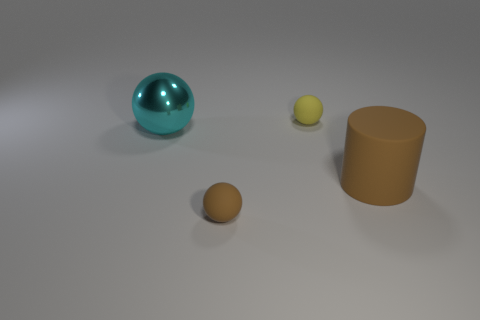There is a ball that is the same color as the matte cylinder; what is it made of?
Give a very brief answer. Rubber. Are the object that is behind the big metallic ball and the big cyan object made of the same material?
Give a very brief answer. No. Is there anything else that is made of the same material as the cyan sphere?
Provide a short and direct response. No. Are there any tiny objects of the same color as the large rubber thing?
Provide a short and direct response. Yes. Do the yellow thing and the metallic thing have the same shape?
Your answer should be very brief. Yes. There is a large cylinder that is made of the same material as the tiny yellow object; what is its color?
Your answer should be compact. Brown. How many things are either small rubber spheres that are in front of the big cyan sphere or cyan things?
Your response must be concise. 2. What is the size of the rubber thing that is behind the big brown object?
Give a very brief answer. Small. Does the metallic ball have the same size as the rubber object that is right of the tiny yellow sphere?
Offer a very short reply. Yes. There is a tiny matte object that is left of the yellow rubber ball behind the cyan sphere; what is its color?
Offer a very short reply. Brown. 